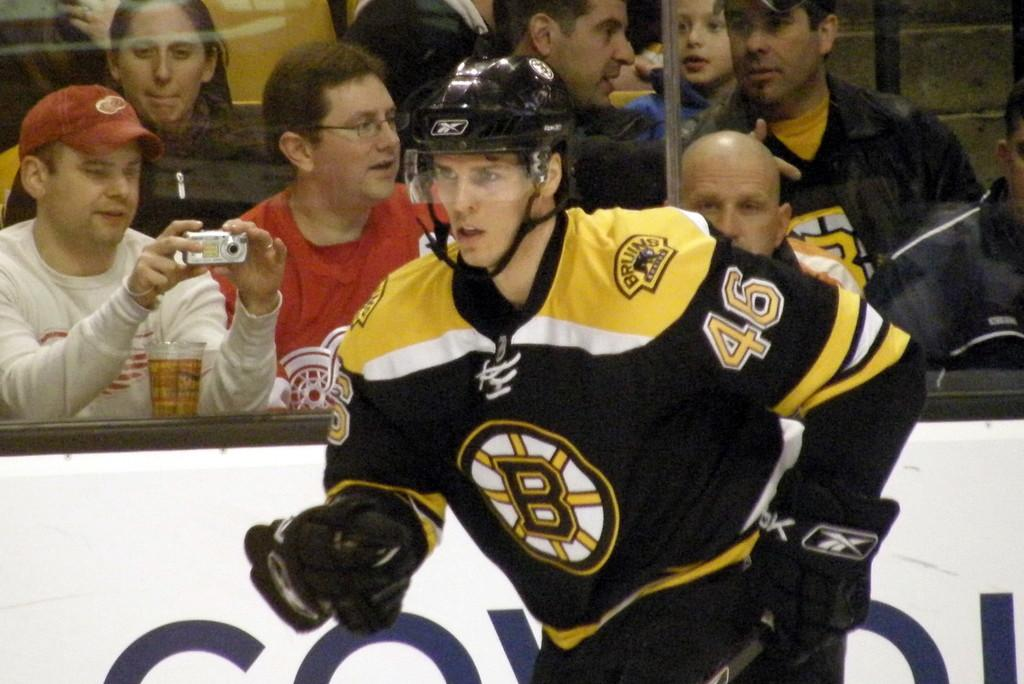<image>
Present a compact description of the photo's key features. A hockey player with the number 46 on his jersey is shown with a crowd of people behind him. 